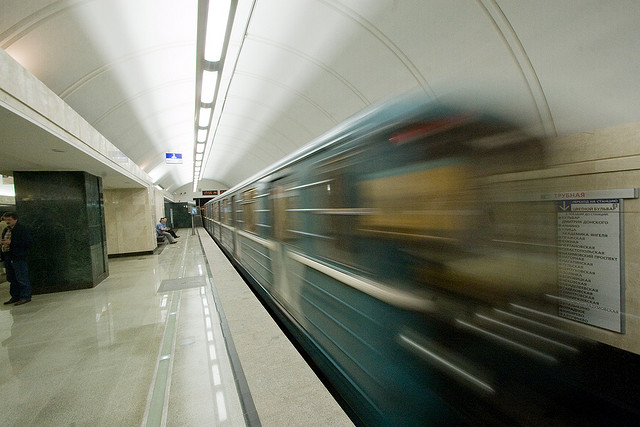Can you infer the potential destinations from the signage in the image? While specific destinations cannot be clearly read from the signage due to the motion blur and angle, it suggests that the information necessary for navigation such as route numbers and station names are displayed for commuters. This is typical of subway systems, indicating direction, transfers, and key points of interest. 